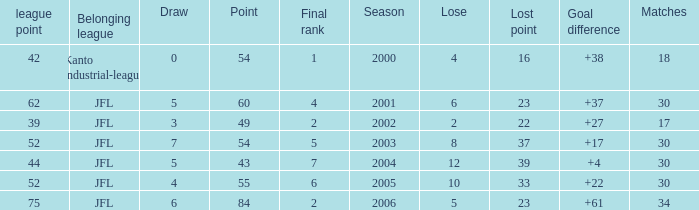Tell me the highest point with lost point being 33 and league point less than 52 None. 